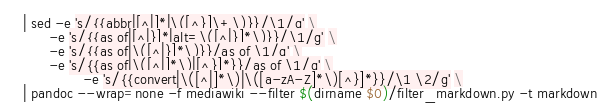Convert code to text. <code><loc_0><loc_0><loc_500><loc_500><_Bash_>  | sed -e 's/{{abbr|[^|]*|\([^}]\+\)}}/\1/g' \
        -e 's/{{as of|[^|}]*|alt=\([^|}]*\)}}/\1/g' \
        -e 's/{{as of|\([^|}]*\)}}/as of \1/g' \
        -e 's/{{as of|\([^|]*\)|[^}]*}}/as of \1/g' \
				-e 's/{{convert|\([^|]*\)|\([a-zA-Z]*\)[^}]*}}/\1 \2/g' \
  | pandoc --wrap=none -f mediawiki --filter $(dirname $0)/filter_markdown.py -t markdown
</code> 